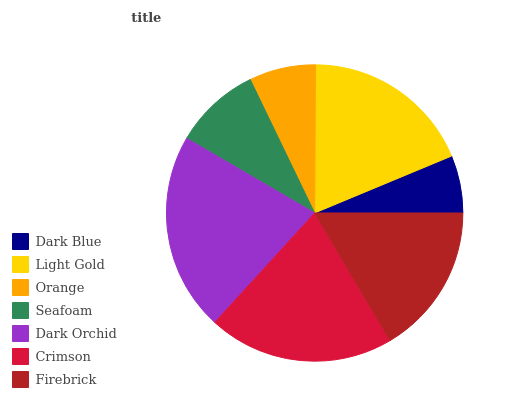Is Dark Blue the minimum?
Answer yes or no. Yes. Is Dark Orchid the maximum?
Answer yes or no. Yes. Is Light Gold the minimum?
Answer yes or no. No. Is Light Gold the maximum?
Answer yes or no. No. Is Light Gold greater than Dark Blue?
Answer yes or no. Yes. Is Dark Blue less than Light Gold?
Answer yes or no. Yes. Is Dark Blue greater than Light Gold?
Answer yes or no. No. Is Light Gold less than Dark Blue?
Answer yes or no. No. Is Firebrick the high median?
Answer yes or no. Yes. Is Firebrick the low median?
Answer yes or no. Yes. Is Light Gold the high median?
Answer yes or no. No. Is Orange the low median?
Answer yes or no. No. 